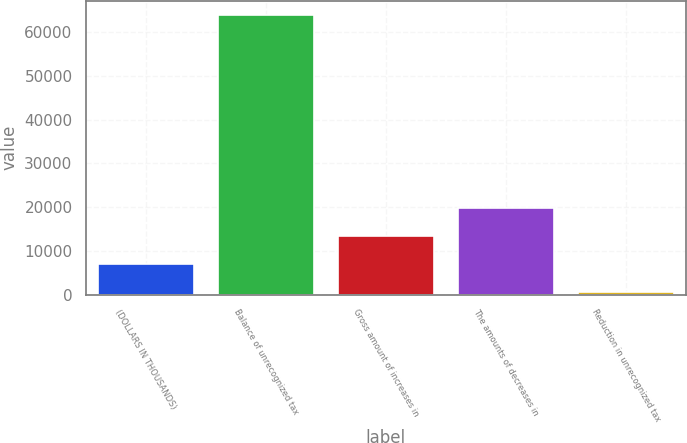Convert chart to OTSL. <chart><loc_0><loc_0><loc_500><loc_500><bar_chart><fcel>(DOLLARS IN THOUSANDS)<fcel>Balance of unrecognized tax<fcel>Gross amount of increases in<fcel>The amounts of decreases in<fcel>Reduction in unrecognized tax<nl><fcel>6924.5<fcel>63928<fcel>13341<fcel>19757.5<fcel>508<nl></chart> 